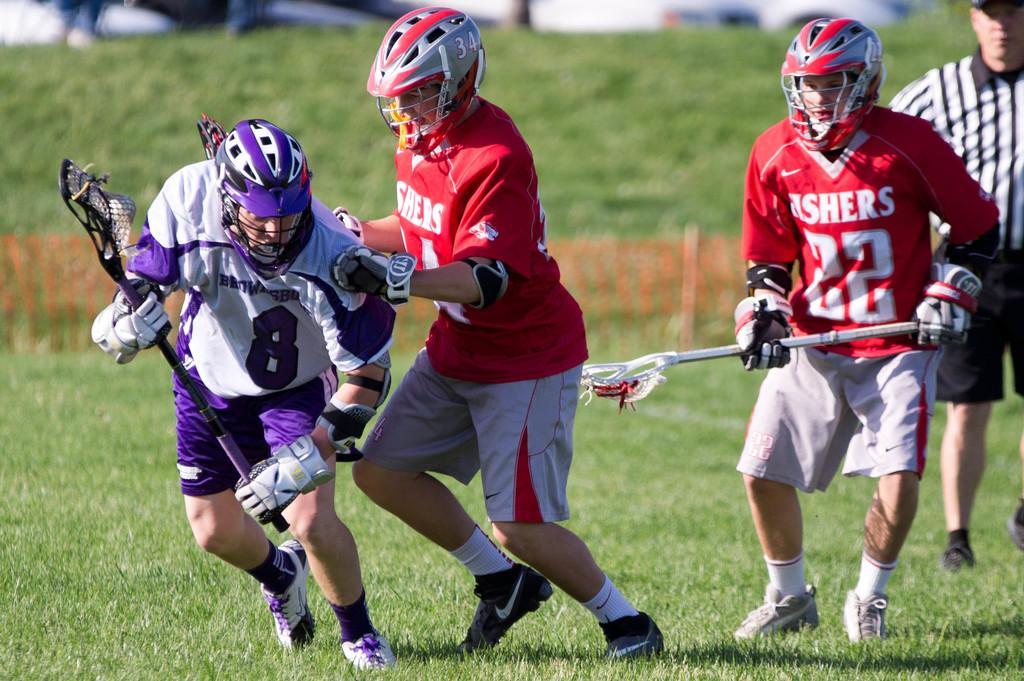Please provide a concise description of this image. In this image in front there are four people running on the grass. Behind them there is a fence. 